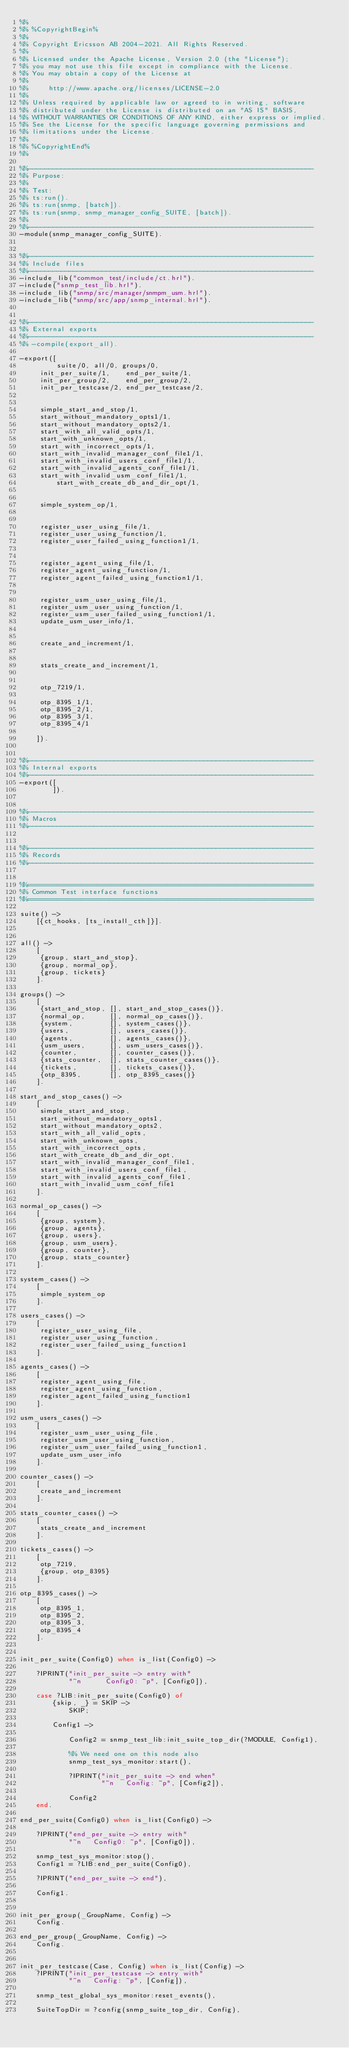<code> <loc_0><loc_0><loc_500><loc_500><_Erlang_>%% 
%% %CopyrightBegin%
%%
%% Copyright Ericsson AB 2004-2021. All Rights Reserved.
%%
%% Licensed under the Apache License, Version 2.0 (the "License");
%% you may not use this file except in compliance with the License.
%% You may obtain a copy of the License at
%%
%%     http://www.apache.org/licenses/LICENSE-2.0
%%
%% Unless required by applicable law or agreed to in writing, software
%% distributed under the License is distributed on an "AS IS" BASIS,
%% WITHOUT WARRANTIES OR CONDITIONS OF ANY KIND, either express or implied.
%% See the License for the specific language governing permissions and
%% limitations under the License.
%%
%% %CopyrightEnd%
%% 

%%----------------------------------------------------------------------
%% Purpose:
%% 
%% Test:
%% ts:run().
%% ts:run(snmp, [batch]).
%% ts:run(snmp, snmp_manager_config_SUITE, [batch]).
%% 
%%----------------------------------------------------------------------
-module(snmp_manager_config_SUITE).


%%----------------------------------------------------------------------
%% Include files
%%----------------------------------------------------------------------
-include_lib("common_test/include/ct.hrl").
-include("snmp_test_lib.hrl").
-include_lib("snmp/src/manager/snmpm_usm.hrl").
-include_lib("snmp/src/app/snmp_internal.hrl").


%%----------------------------------------------------------------------
%% External exports
%%----------------------------------------------------------------------
%% -compile(export_all).

-export([
         suite/0, all/0, groups/0,
	 init_per_suite/1,    end_per_suite/1, 
	 init_per_group/2,    end_per_group/2, 
	 init_per_testcase/2, end_per_testcase/2, 


	 simple_start_and_stop/1,
	 start_without_mandatory_opts1/1,
	 start_without_mandatory_opts2/1,
	 start_with_all_valid_opts/1,
	 start_with_unknown_opts/1,
	 start_with_incorrect_opts/1,
	 start_with_invalid_manager_conf_file1/1,
	 start_with_invalid_users_conf_file1/1,
	 start_with_invalid_agents_conf_file1/1,
	 start_with_invalid_usm_conf_file1/1,
         start_with_create_db_and_dir_opt/1,

	
	 simple_system_op/1,

	
	 register_user_using_file/1,
	 register_user_using_function/1,
	 register_user_failed_using_function1/1,

	
	 register_agent_using_file/1,
	 register_agent_using_function/1,
	 register_agent_failed_using_function1/1,

	
	 register_usm_user_using_file/1,
	 register_usm_user_using_function/1,
	 register_usm_user_failed_using_function1/1,
	 update_usm_user_info/1, 

	
	 create_and_increment/1,

	
	 stats_create_and_increment/1,

	
	 otp_7219/1, 
	 
	 otp_8395_1/1, 
	 otp_8395_2/1, 
	 otp_8395_3/1, 
	 otp_8395_4/1

	]).


%%----------------------------------------------------------------------
%% Internal exports
%%----------------------------------------------------------------------
-export([
        ]).


%%----------------------------------------------------------------------
%% Macros
%%----------------------------------------------------------------------


%%----------------------------------------------------------------------
%% Records
%%----------------------------------------------------------------------


%%======================================================================
%% Common Test interface functions
%%======================================================================

suite() -> 
    [{ct_hooks, [ts_install_cth]}].


all() -> 
    [
     {group, start_and_stop},
     {group, normal_op},
     {group, tickets}
    ].

groups() -> 
    [
     {start_and_stop, [], start_and_stop_cases()},
     {normal_op,      [], normal_op_cases()},
     {system,         [], system_cases()},
     {users,          [], users_cases()},
     {agents,         [], agents_cases()},
     {usm_users,      [], usm_users_cases()},
     {counter,        [], counter_cases()},
     {stats_counter,  [], stats_counter_cases()},
     {tickets,        [], tickets_cases()},
     {otp_8395,       [], otp_8395_cases()}
    ].

start_and_stop_cases() ->
    [
     simple_start_and_stop, 
     start_without_mandatory_opts1,
     start_without_mandatory_opts2,
     start_with_all_valid_opts,
     start_with_unknown_opts,
     start_with_incorrect_opts,
     start_with_create_db_and_dir_opt,
     start_with_invalid_manager_conf_file1,
     start_with_invalid_users_conf_file1,
     start_with_invalid_agents_conf_file1,
     start_with_invalid_usm_conf_file1
    ].

normal_op_cases() ->
    [
     {group, system}, 
     {group, agents}, 
     {group, users},
     {group, usm_users}, 
     {group, counter},
     {group, stats_counter}
    ].

system_cases() ->
    [
     simple_system_op
    ].

users_cases() ->
    [
     register_user_using_file, 
     register_user_using_function,
     register_user_failed_using_function1
    ].

agents_cases() ->
    [
     register_agent_using_file,
     register_agent_using_function,
     register_agent_failed_using_function1
    ].

usm_users_cases() ->
    [
     register_usm_user_using_file,
     register_usm_user_using_function,
     register_usm_user_failed_using_function1,
     update_usm_user_info
    ].

counter_cases() ->
    [
     create_and_increment
    ].

stats_counter_cases() ->
    [
     stats_create_and_increment
    ].

tickets_cases() ->
    [
     otp_7219,
     {group, otp_8395}
    ].

otp_8395_cases() ->
    [
     otp_8395_1,
     otp_8395_2,
     otp_8395_3,
     otp_8395_4
    ].


init_per_suite(Config0) when is_list(Config0) ->

    ?IPRINT("init_per_suite -> entry with"
            "~n      Config0: ~p", [Config0]),

    case ?LIB:init_per_suite(Config0) of
        {skip, _} = SKIP ->
            SKIP;

        Config1 ->

            Config2 = snmp_test_lib:init_suite_top_dir(?MODULE, Config1), 

            %% We need one on this node also
            snmp_test_sys_monitor:start(),

            ?IPRINT("init_per_suite -> end when"
                    "~n   Config: ~p", [Config2]),

            Config2
    end.

end_per_suite(Config0) when is_list(Config0) ->

    ?IPRINT("end_per_suite -> entry with"
            "~n   Config0: ~p", [Config0]),

    snmp_test_sys_monitor:stop(),
    Config1 = ?LIB:end_per_suite(Config0),

    ?IPRINT("end_per_suite -> end"),

    Config1.


init_per_group(_GroupName, Config) ->
    Config.

end_per_group(_GroupName, Config) ->
    Config.


init_per_testcase(Case, Config) when is_list(Config) ->
    ?IPRINT("init_per_testcase -> entry with"
            "~n   Config: ~p", [Config]),

    snmp_test_global_sys_monitor:reset_events(),

    SuiteTopDir = ?config(snmp_suite_top_dir, Config),</code> 